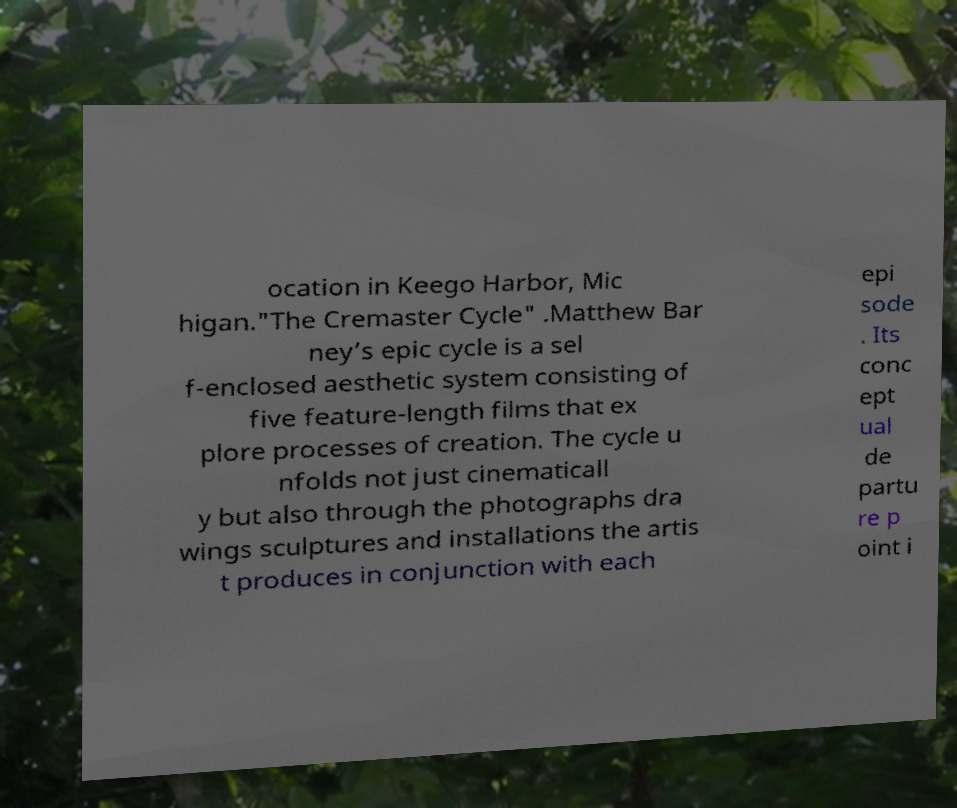Please identify and transcribe the text found in this image. ocation in Keego Harbor, Mic higan."The Cremaster Cycle" .Matthew Bar ney’s epic cycle is a sel f-enclosed aesthetic system consisting of five feature-length films that ex plore processes of creation. The cycle u nfolds not just cinematicall y but also through the photographs dra wings sculptures and installations the artis t produces in conjunction with each epi sode . Its conc ept ual de partu re p oint i 